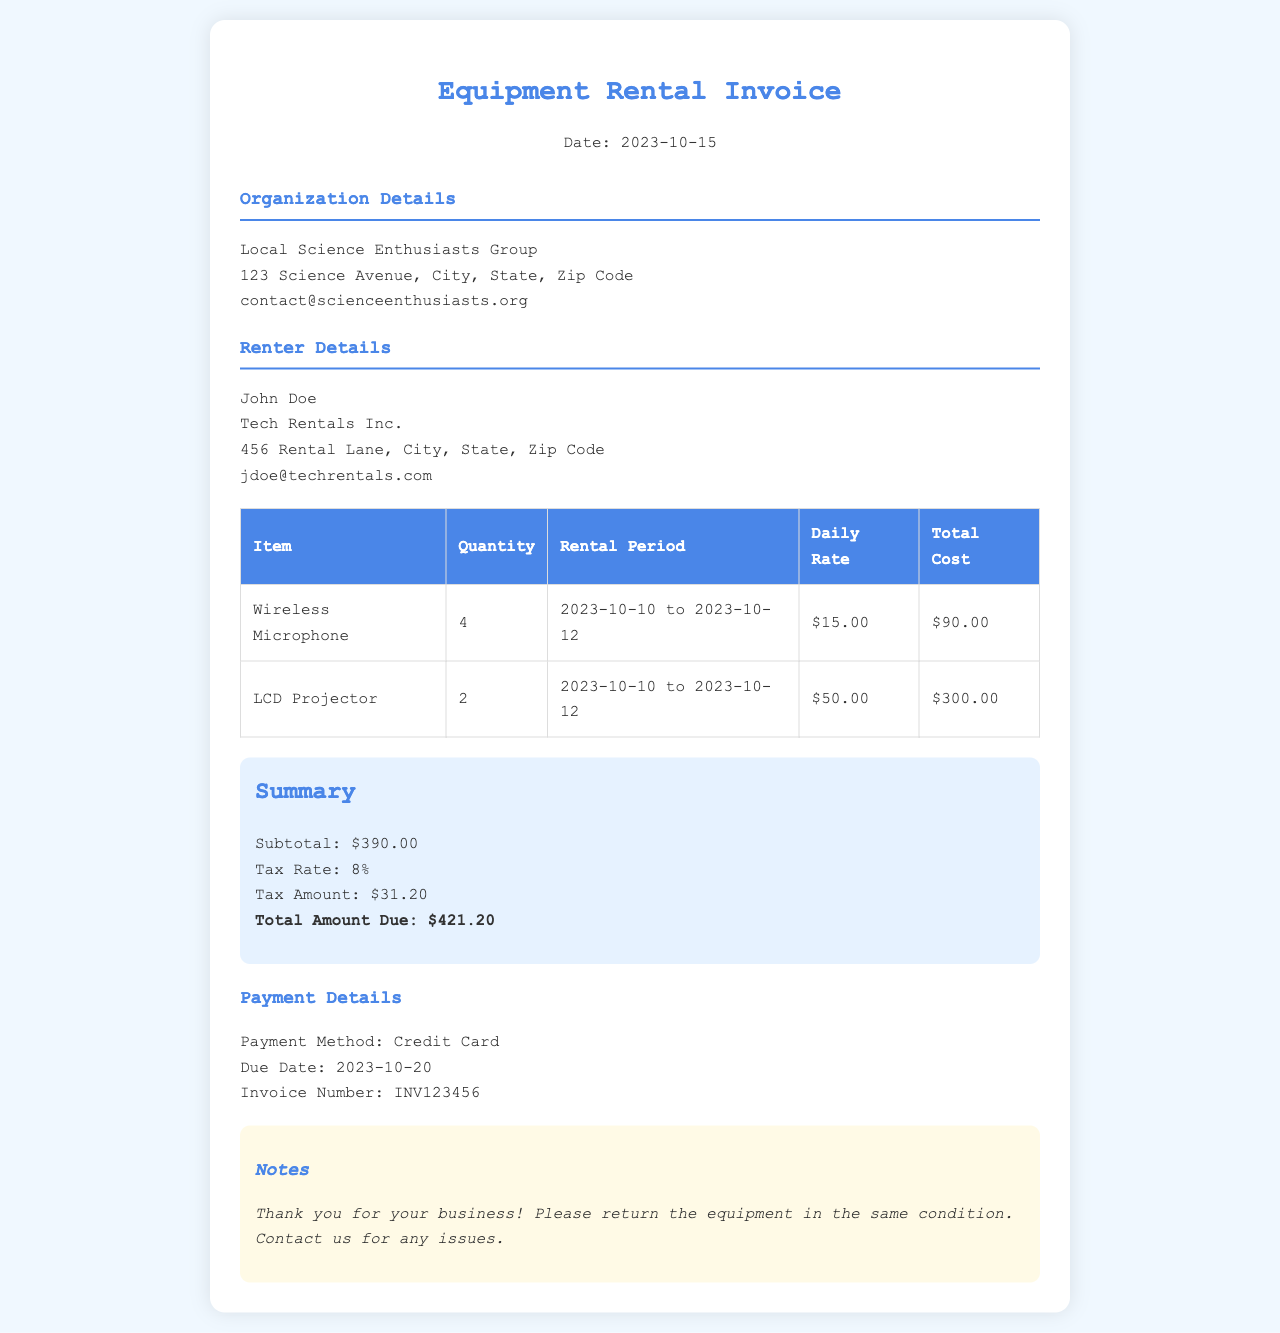What is the date of the invoice? The date of the invoice is clearly stated at the top of the document.
Answer: 2023-10-15 How many wireless microphones were rented? The number of wireless microphones rented is indicated in the table under the quantity column.
Answer: 4 What is the rental period for the LCD projector? The rental period for the LCD projector is listed beside each item in the table of rentals.
Answer: 2023-10-10 to 2023-10-12 What is the total cost for the microphones? The total cost for the microphones can be determined from the total cost column in the table.
Answer: $90.00 How much tax is included in the total amount due? The tax amount is detailed in the summary section of the invoice.
Answer: $31.20 What is the payment method used? The payment method is specified in the payment details section towards the end of the document.
Answer: Credit Card What is the invoice number? The invoice number can be found in the payment details section.
Answer: INV123456 How many days were the items rented for? The rental period for the items is stated explicitly in the table, and the duration can be calculated based on the start and end dates.
Answer: 3 days What organization is renting the equipment? The renter's organization is mentioned at the top of the document under Renter Details.
Answer: Tech Rentals Inc What is the total amount due? The total amount due is given in the summary section, which includes all fees and taxes.
Answer: $421.20 